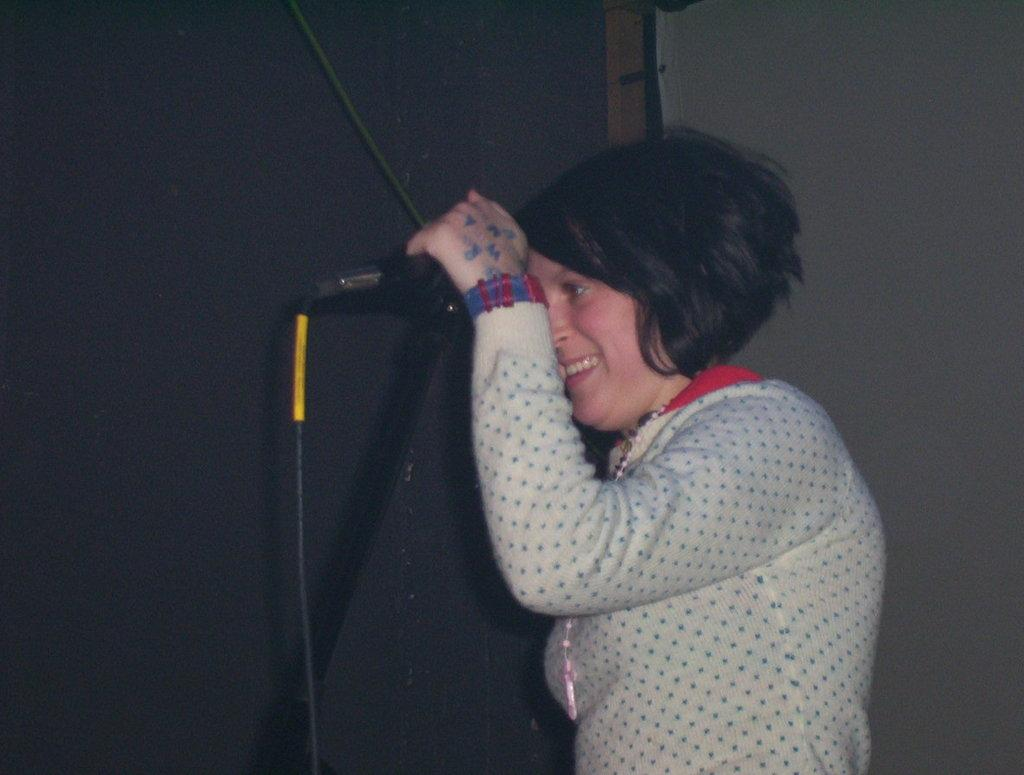Who is the main subject in the image? There is a woman in the image. What is the woman doing in the image? The woman is standing in front of a microphone. What can be seen behind the woman in the image? There is a wall visible behind the woman. What type of disease is the woman discussing in the image? There is no indication in the image that the woman is discussing any disease. 